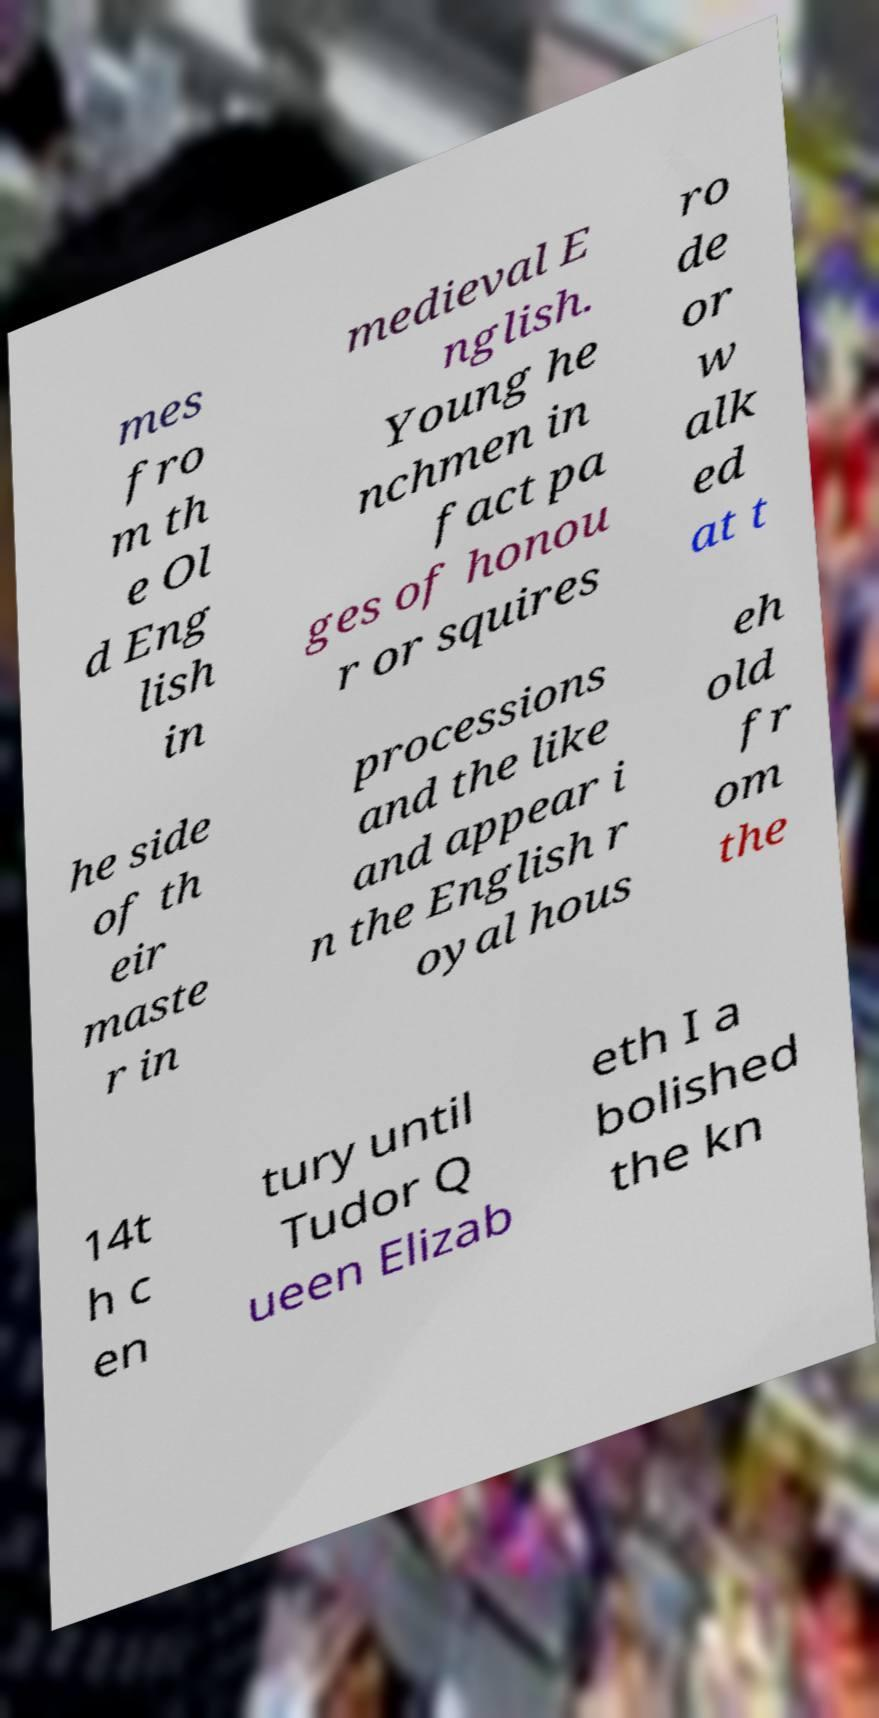Could you extract and type out the text from this image? mes fro m th e Ol d Eng lish in medieval E nglish. Young he nchmen in fact pa ges of honou r or squires ro de or w alk ed at t he side of th eir maste r in processions and the like and appear i n the English r oyal hous eh old fr om the 14t h c en tury until Tudor Q ueen Elizab eth I a bolished the kn 